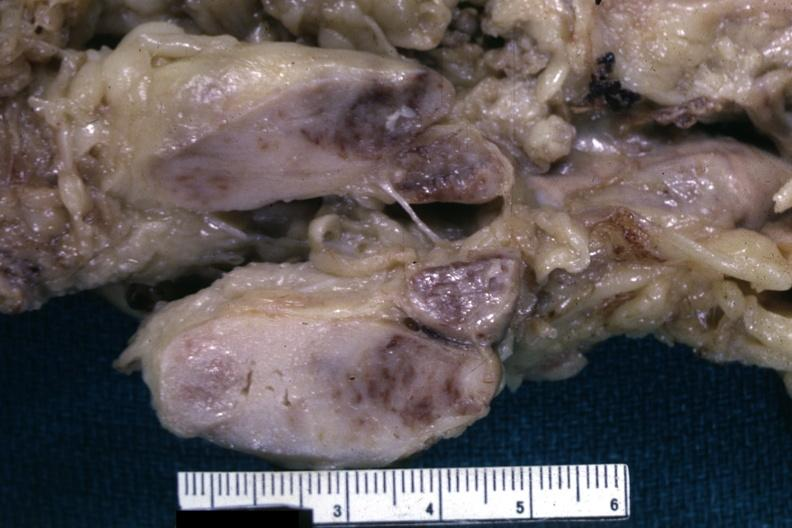what is matting history of this case see other slides?
Answer the question using a single word or phrase. Unknown could have been a seminoma 